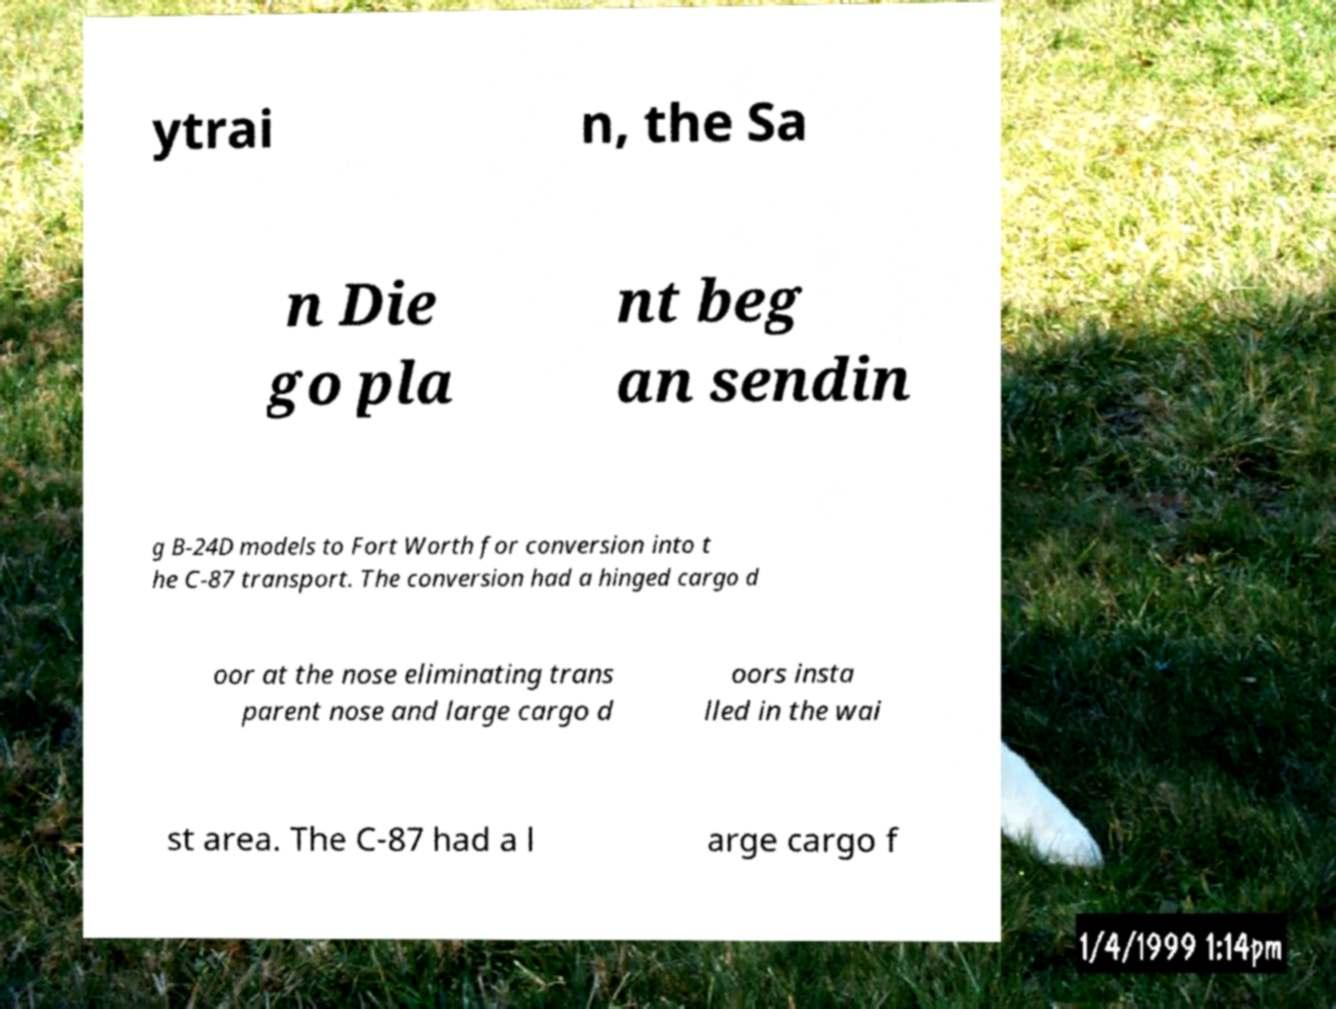Can you accurately transcribe the text from the provided image for me? ytrai n, the Sa n Die go pla nt beg an sendin g B-24D models to Fort Worth for conversion into t he C-87 transport. The conversion had a hinged cargo d oor at the nose eliminating trans parent nose and large cargo d oors insta lled in the wai st area. The C-87 had a l arge cargo f 